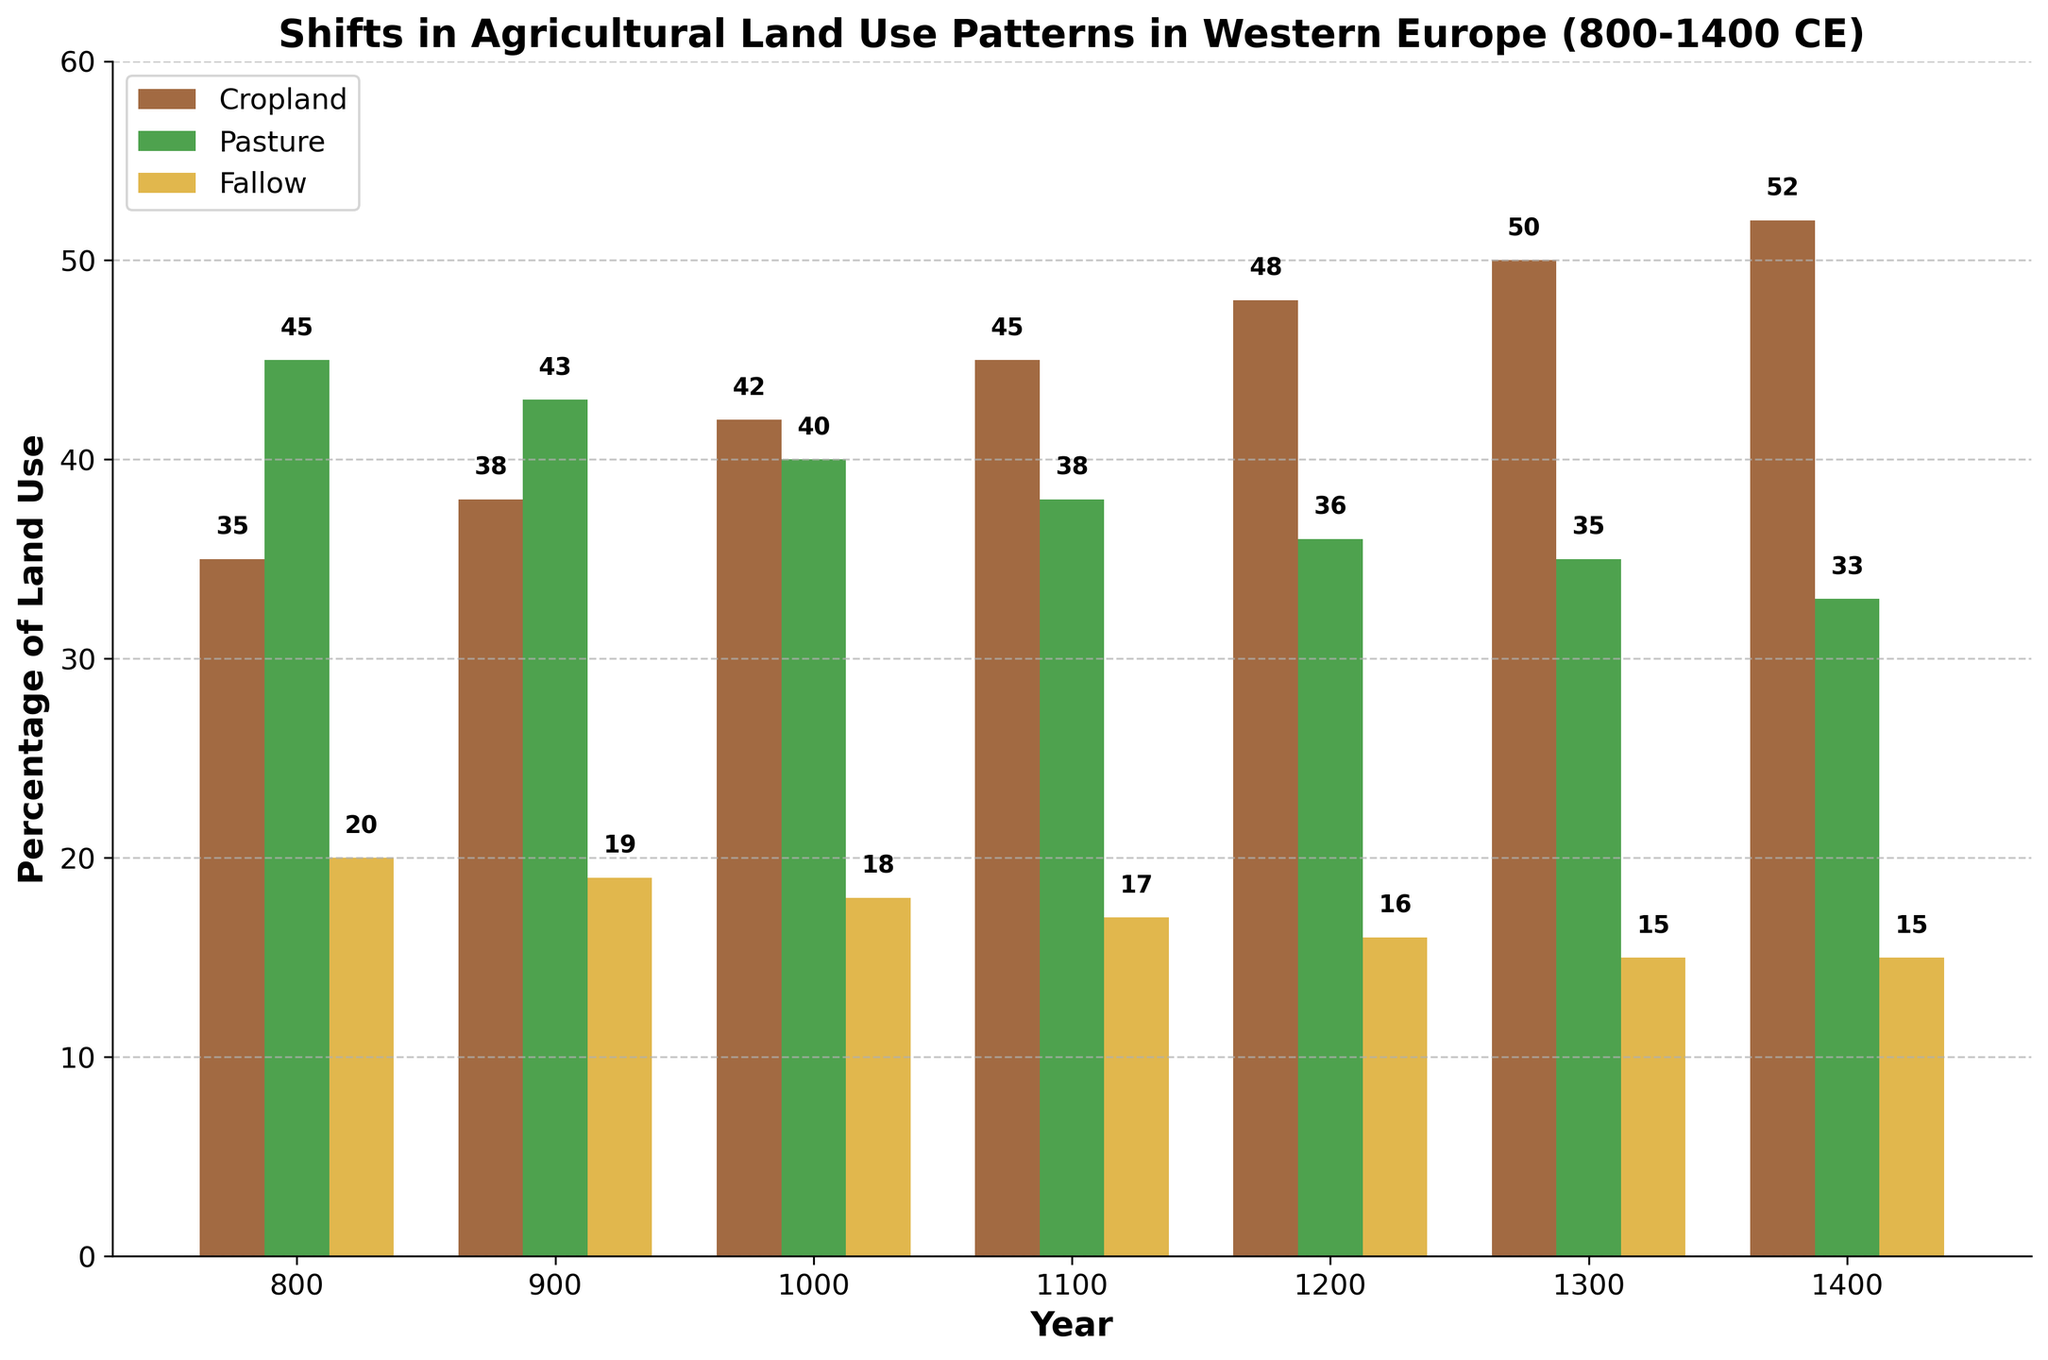What is the percentage increase in cropland from 800 CE to 1400 CE? To find the percentage increase, subtract the initial percentage (35% in 800 CE) from the final percentage (52% in 1400 CE). The increase is 52% - 35% = 17%.
Answer: 17% Which land use category increased the most between 800 CE and 1400 CE? Compare the percentage changes for cropland, pasture, and fallow. Cropland increased from 35% to 52% (17%), pasture decreased from 45% to 33% (-12%), and fallow decreased from 20% to 15% (-5%). Cropland had the highest increase of 17%.
Answer: Cropland In which century did the percentage of cropland first reach 45% or more? Check the data to find the first year where the cropland percentage is 45% or higher. This occurs in 1100 CE, which is in the 12th century.
Answer: 12th century How did the land use for pasture change from 900 CE to 1100 CE? Find the percentages for pasture in 900 CE (43%) and 1100 CE (38%). Subtract the value in 1100 CE from that in 900 CE: 43% - 38% = 5%. Pasture decreased by 5%.
Answer: Decreased by 5% In which year did the percentage of land left fallow remain the same as the previous century? Identify years where the fallow percentage did not change from one century to the next. From 1300 CE to 1400 CE, the percentage remained at 15%.
Answer: 1400 CE What is the overall trend in the proportion of land left fallow from 800 CE to 1400 CE? Observe the trend in the fallow percentages from the years provided. The fallow percentages decrease from 20% in 800 CE to 15% in 1400 CE.
Answer: Decreasing How does the percentage of cropland in 1200 CE compare to that of pasture in 1200 CE? Look at the values for 1200 CE: Cropland is 48% and pasture is 36%. Cropland's percentage is higher than that of pasture.
Answer: Cropland is higher What is the combined percentage of cropland and fallow land in 900 CE? Add the cropland percentage (38%) and fallow percentage (19%) for 900 CE: 38% + 19% = 57%.
Answer: 57% Which land use category shows the most stability (least change) over the period from 800 CE to 1400 CE? Analyze the overall changes: Cropland increased by 17%, pasture decreased by 12%, and fallow decreased by 5%. Fallow land shows the smallest change.
Answer: Fallow Is the percentage of pasture in 1300 CE greater than the percentage of cropland in 1000 CE? Compare the pasture percentage in 1300 CE (35%) to the cropland percentage in 1000 CE (42%). 35% is less than 42%.
Answer: No 